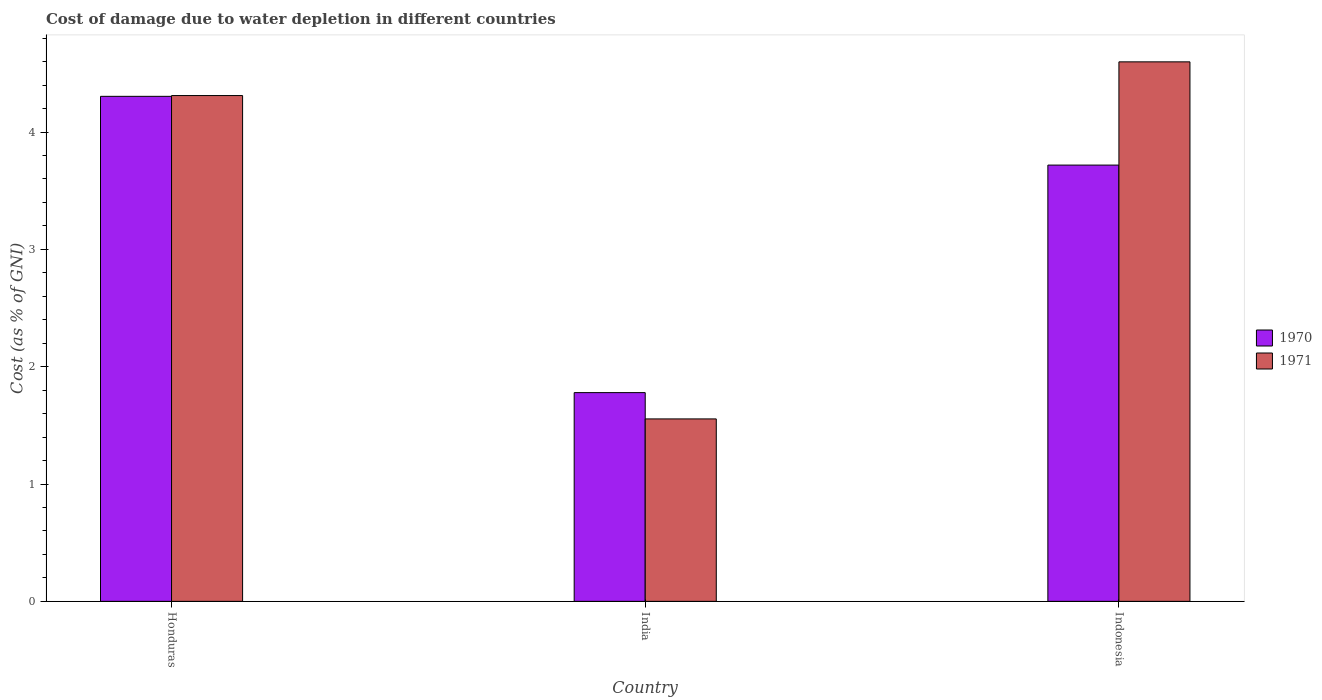How many groups of bars are there?
Ensure brevity in your answer.  3. Are the number of bars on each tick of the X-axis equal?
Offer a very short reply. Yes. What is the cost of damage caused due to water depletion in 1971 in India?
Provide a succinct answer. 1.55. Across all countries, what is the maximum cost of damage caused due to water depletion in 1970?
Keep it short and to the point. 4.3. Across all countries, what is the minimum cost of damage caused due to water depletion in 1970?
Give a very brief answer. 1.78. In which country was the cost of damage caused due to water depletion in 1970 maximum?
Offer a terse response. Honduras. What is the total cost of damage caused due to water depletion in 1971 in the graph?
Provide a short and direct response. 10.46. What is the difference between the cost of damage caused due to water depletion in 1970 in Honduras and that in India?
Make the answer very short. 2.53. What is the difference between the cost of damage caused due to water depletion in 1970 in India and the cost of damage caused due to water depletion in 1971 in Honduras?
Make the answer very short. -2.53. What is the average cost of damage caused due to water depletion in 1971 per country?
Ensure brevity in your answer.  3.49. What is the difference between the cost of damage caused due to water depletion of/in 1971 and cost of damage caused due to water depletion of/in 1970 in Indonesia?
Provide a succinct answer. 0.88. In how many countries, is the cost of damage caused due to water depletion in 1970 greater than 3 %?
Your answer should be compact. 2. What is the ratio of the cost of damage caused due to water depletion in 1971 in India to that in Indonesia?
Ensure brevity in your answer.  0.34. Is the cost of damage caused due to water depletion in 1970 in Honduras less than that in India?
Offer a terse response. No. What is the difference between the highest and the second highest cost of damage caused due to water depletion in 1971?
Ensure brevity in your answer.  -3.04. What is the difference between the highest and the lowest cost of damage caused due to water depletion in 1970?
Your answer should be very brief. 2.53. Is the sum of the cost of damage caused due to water depletion in 1971 in Honduras and India greater than the maximum cost of damage caused due to water depletion in 1970 across all countries?
Offer a very short reply. Yes. What does the 1st bar from the left in Indonesia represents?
Ensure brevity in your answer.  1970. What does the 1st bar from the right in Indonesia represents?
Your response must be concise. 1971. Are all the bars in the graph horizontal?
Ensure brevity in your answer.  No. Where does the legend appear in the graph?
Keep it short and to the point. Center right. What is the title of the graph?
Your answer should be compact. Cost of damage due to water depletion in different countries. What is the label or title of the Y-axis?
Your answer should be very brief. Cost (as % of GNI). What is the Cost (as % of GNI) in 1970 in Honduras?
Make the answer very short. 4.3. What is the Cost (as % of GNI) in 1971 in Honduras?
Your answer should be very brief. 4.31. What is the Cost (as % of GNI) of 1970 in India?
Provide a short and direct response. 1.78. What is the Cost (as % of GNI) in 1971 in India?
Ensure brevity in your answer.  1.55. What is the Cost (as % of GNI) of 1970 in Indonesia?
Your answer should be compact. 3.72. What is the Cost (as % of GNI) of 1971 in Indonesia?
Ensure brevity in your answer.  4.6. Across all countries, what is the maximum Cost (as % of GNI) of 1970?
Ensure brevity in your answer.  4.3. Across all countries, what is the maximum Cost (as % of GNI) of 1971?
Give a very brief answer. 4.6. Across all countries, what is the minimum Cost (as % of GNI) of 1970?
Your answer should be very brief. 1.78. Across all countries, what is the minimum Cost (as % of GNI) of 1971?
Keep it short and to the point. 1.55. What is the total Cost (as % of GNI) of 1970 in the graph?
Ensure brevity in your answer.  9.8. What is the total Cost (as % of GNI) in 1971 in the graph?
Your answer should be compact. 10.46. What is the difference between the Cost (as % of GNI) in 1970 in Honduras and that in India?
Keep it short and to the point. 2.53. What is the difference between the Cost (as % of GNI) in 1971 in Honduras and that in India?
Provide a succinct answer. 2.76. What is the difference between the Cost (as % of GNI) in 1970 in Honduras and that in Indonesia?
Provide a succinct answer. 0.59. What is the difference between the Cost (as % of GNI) of 1971 in Honduras and that in Indonesia?
Give a very brief answer. -0.29. What is the difference between the Cost (as % of GNI) of 1970 in India and that in Indonesia?
Offer a very short reply. -1.94. What is the difference between the Cost (as % of GNI) of 1971 in India and that in Indonesia?
Offer a terse response. -3.04. What is the difference between the Cost (as % of GNI) of 1970 in Honduras and the Cost (as % of GNI) of 1971 in India?
Offer a terse response. 2.75. What is the difference between the Cost (as % of GNI) of 1970 in Honduras and the Cost (as % of GNI) of 1971 in Indonesia?
Offer a very short reply. -0.29. What is the difference between the Cost (as % of GNI) in 1970 in India and the Cost (as % of GNI) in 1971 in Indonesia?
Offer a very short reply. -2.82. What is the average Cost (as % of GNI) in 1970 per country?
Your response must be concise. 3.27. What is the average Cost (as % of GNI) in 1971 per country?
Your answer should be compact. 3.49. What is the difference between the Cost (as % of GNI) in 1970 and Cost (as % of GNI) in 1971 in Honduras?
Provide a succinct answer. -0.01. What is the difference between the Cost (as % of GNI) of 1970 and Cost (as % of GNI) of 1971 in India?
Your answer should be compact. 0.22. What is the difference between the Cost (as % of GNI) of 1970 and Cost (as % of GNI) of 1971 in Indonesia?
Provide a succinct answer. -0.88. What is the ratio of the Cost (as % of GNI) of 1970 in Honduras to that in India?
Your answer should be compact. 2.42. What is the ratio of the Cost (as % of GNI) of 1971 in Honduras to that in India?
Provide a short and direct response. 2.77. What is the ratio of the Cost (as % of GNI) in 1970 in Honduras to that in Indonesia?
Provide a short and direct response. 1.16. What is the ratio of the Cost (as % of GNI) in 1970 in India to that in Indonesia?
Offer a very short reply. 0.48. What is the ratio of the Cost (as % of GNI) of 1971 in India to that in Indonesia?
Keep it short and to the point. 0.34. What is the difference between the highest and the second highest Cost (as % of GNI) in 1970?
Offer a very short reply. 0.59. What is the difference between the highest and the second highest Cost (as % of GNI) of 1971?
Your response must be concise. 0.29. What is the difference between the highest and the lowest Cost (as % of GNI) in 1970?
Keep it short and to the point. 2.53. What is the difference between the highest and the lowest Cost (as % of GNI) in 1971?
Offer a very short reply. 3.04. 